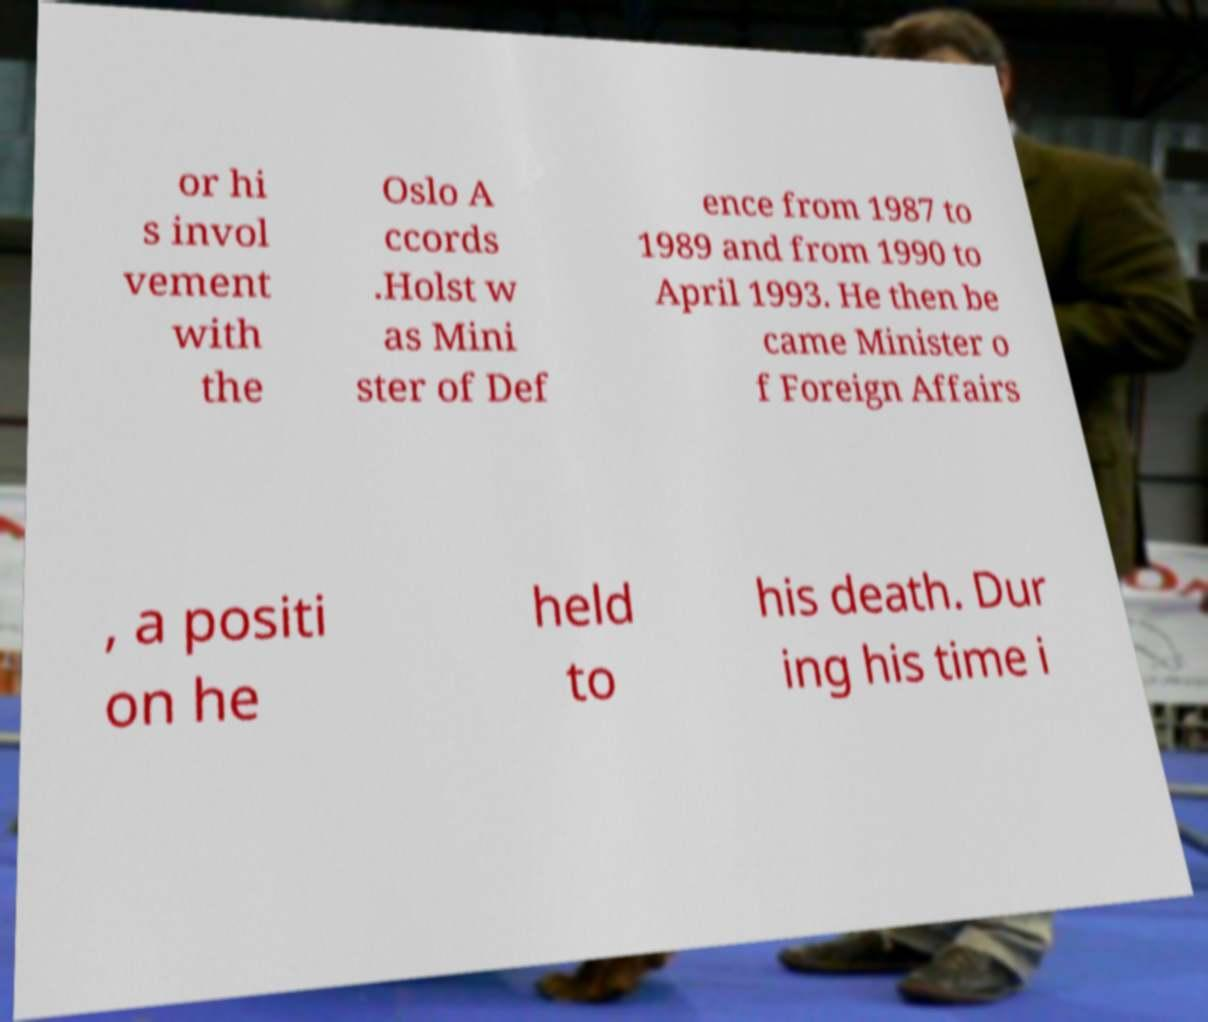Can you read and provide the text displayed in the image?This photo seems to have some interesting text. Can you extract and type it out for me? or hi s invol vement with the Oslo A ccords .Holst w as Mini ster of Def ence from 1987 to 1989 and from 1990 to April 1993. He then be came Minister o f Foreign Affairs , a positi on he held to his death. Dur ing his time i 